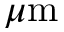Convert formula to latex. <formula><loc_0><loc_0><loc_500><loc_500>\mu m</formula> 